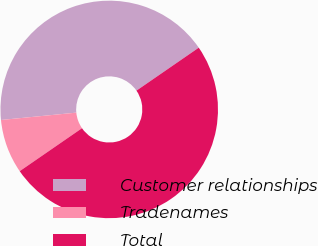Convert chart. <chart><loc_0><loc_0><loc_500><loc_500><pie_chart><fcel>Customer relationships<fcel>Tradenames<fcel>Total<nl><fcel>41.94%<fcel>8.06%<fcel>50.0%<nl></chart> 